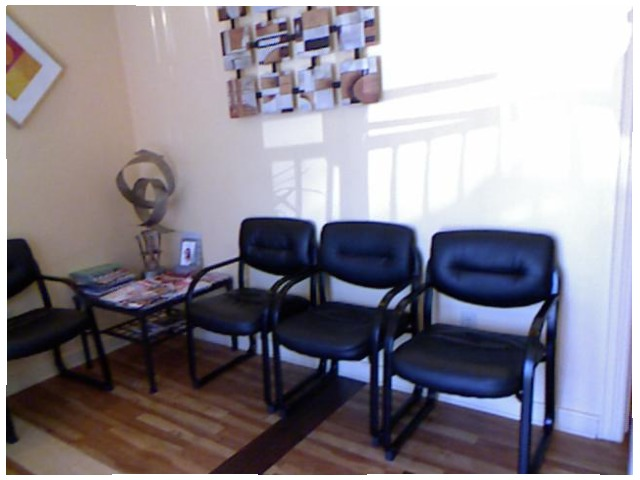<image>
Can you confirm if the figurine is next to the chair? Yes. The figurine is positioned adjacent to the chair, located nearby in the same general area. Is there a table next to the chair? Yes. The table is positioned adjacent to the chair, located nearby in the same general area. 